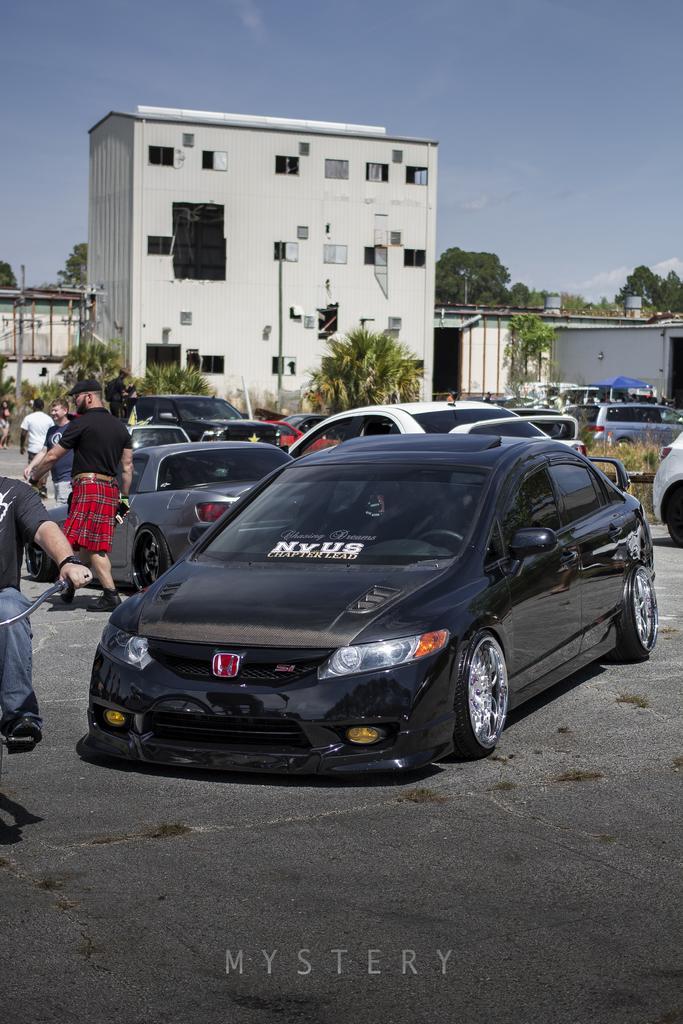Could you give a brief overview of what you see in this image? In this picture I can see there are few cars parked on the road and on to left we can find there are few people walking and in the backdrop I can see there are trees, buildings, poles and the sky is clear. 